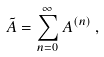Convert formula to latex. <formula><loc_0><loc_0><loc_500><loc_500>\tilde { A } = \sum _ { n = 0 } ^ { \infty } A ^ { ( n ) } \, ,</formula> 